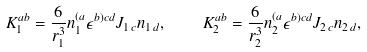Convert formula to latex. <formula><loc_0><loc_0><loc_500><loc_500>K _ { 1 } ^ { a b } = \frac { 6 } { r _ { 1 } ^ { 3 } } n _ { 1 } ^ { ( a } \epsilon ^ { b ) c d } J _ { 1 \, c } n _ { 1 \, d } , \quad K _ { 2 } ^ { a b } = \frac { 6 } { r _ { 2 } ^ { 3 } } n _ { 2 } ^ { ( a } \epsilon ^ { b ) c d } J _ { 2 \, c } n _ { 2 \, d } ,</formula> 